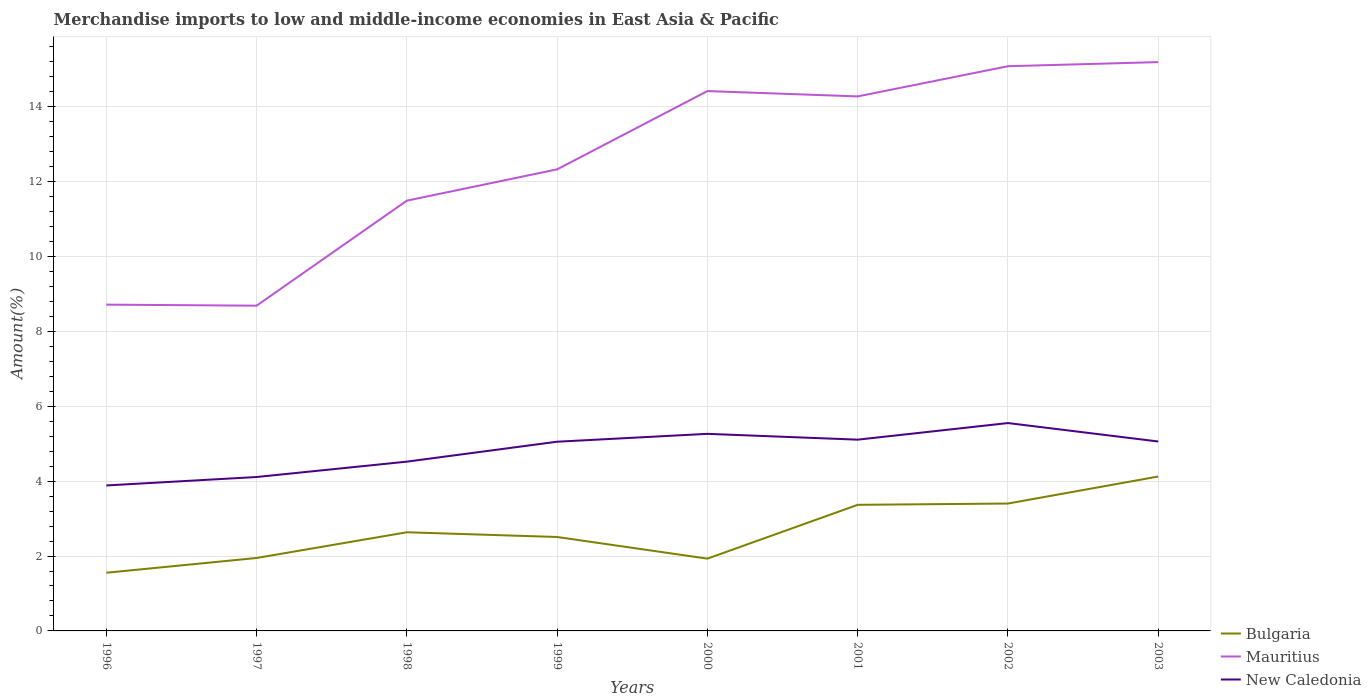How many different coloured lines are there?
Ensure brevity in your answer.  3. Across all years, what is the maximum percentage of amount earned from merchandise imports in Mauritius?
Offer a terse response. 8.69. In which year was the percentage of amount earned from merchandise imports in Mauritius maximum?
Make the answer very short. 1997. What is the total percentage of amount earned from merchandise imports in New Caledonia in the graph?
Your answer should be compact. -1.44. What is the difference between the highest and the second highest percentage of amount earned from merchandise imports in New Caledonia?
Offer a terse response. 1.67. What is the difference between the highest and the lowest percentage of amount earned from merchandise imports in Mauritius?
Provide a succinct answer. 4. How many years are there in the graph?
Offer a very short reply. 8. What is the difference between two consecutive major ticks on the Y-axis?
Provide a succinct answer. 2. Does the graph contain grids?
Give a very brief answer. Yes. How many legend labels are there?
Ensure brevity in your answer.  3. What is the title of the graph?
Offer a very short reply. Merchandise imports to low and middle-income economies in East Asia & Pacific. What is the label or title of the Y-axis?
Your answer should be very brief. Amount(%). What is the Amount(%) of Bulgaria in 1996?
Provide a short and direct response. 1.55. What is the Amount(%) in Mauritius in 1996?
Provide a succinct answer. 8.71. What is the Amount(%) in New Caledonia in 1996?
Your response must be concise. 3.88. What is the Amount(%) in Bulgaria in 1997?
Keep it short and to the point. 1.95. What is the Amount(%) of Mauritius in 1997?
Make the answer very short. 8.69. What is the Amount(%) in New Caledonia in 1997?
Make the answer very short. 4.11. What is the Amount(%) of Bulgaria in 1998?
Provide a short and direct response. 2.63. What is the Amount(%) in Mauritius in 1998?
Provide a succinct answer. 11.49. What is the Amount(%) of New Caledonia in 1998?
Give a very brief answer. 4.52. What is the Amount(%) in Bulgaria in 1999?
Your answer should be compact. 2.51. What is the Amount(%) of Mauritius in 1999?
Your answer should be compact. 12.33. What is the Amount(%) in New Caledonia in 1999?
Your answer should be compact. 5.05. What is the Amount(%) of Bulgaria in 2000?
Your response must be concise. 1.93. What is the Amount(%) in Mauritius in 2000?
Make the answer very short. 14.42. What is the Amount(%) in New Caledonia in 2000?
Your answer should be very brief. 5.26. What is the Amount(%) of Bulgaria in 2001?
Offer a very short reply. 3.37. What is the Amount(%) of Mauritius in 2001?
Give a very brief answer. 14.27. What is the Amount(%) in New Caledonia in 2001?
Provide a short and direct response. 5.11. What is the Amount(%) of Bulgaria in 2002?
Your answer should be very brief. 3.4. What is the Amount(%) of Mauritius in 2002?
Keep it short and to the point. 15.08. What is the Amount(%) of New Caledonia in 2002?
Offer a very short reply. 5.55. What is the Amount(%) in Bulgaria in 2003?
Ensure brevity in your answer.  4.12. What is the Amount(%) in Mauritius in 2003?
Ensure brevity in your answer.  15.19. What is the Amount(%) of New Caledonia in 2003?
Provide a short and direct response. 5.06. Across all years, what is the maximum Amount(%) in Bulgaria?
Provide a succinct answer. 4.12. Across all years, what is the maximum Amount(%) in Mauritius?
Ensure brevity in your answer.  15.19. Across all years, what is the maximum Amount(%) of New Caledonia?
Keep it short and to the point. 5.55. Across all years, what is the minimum Amount(%) of Bulgaria?
Make the answer very short. 1.55. Across all years, what is the minimum Amount(%) in Mauritius?
Provide a short and direct response. 8.69. Across all years, what is the minimum Amount(%) in New Caledonia?
Your response must be concise. 3.88. What is the total Amount(%) of Bulgaria in the graph?
Keep it short and to the point. 21.47. What is the total Amount(%) in Mauritius in the graph?
Give a very brief answer. 100.18. What is the total Amount(%) in New Caledonia in the graph?
Your answer should be compact. 38.55. What is the difference between the Amount(%) in Bulgaria in 1996 and that in 1997?
Provide a succinct answer. -0.39. What is the difference between the Amount(%) of Mauritius in 1996 and that in 1997?
Offer a terse response. 0.03. What is the difference between the Amount(%) in New Caledonia in 1996 and that in 1997?
Offer a terse response. -0.23. What is the difference between the Amount(%) of Bulgaria in 1996 and that in 1998?
Offer a terse response. -1.08. What is the difference between the Amount(%) in Mauritius in 1996 and that in 1998?
Keep it short and to the point. -2.78. What is the difference between the Amount(%) of New Caledonia in 1996 and that in 1998?
Your response must be concise. -0.64. What is the difference between the Amount(%) of Bulgaria in 1996 and that in 1999?
Provide a short and direct response. -0.95. What is the difference between the Amount(%) in Mauritius in 1996 and that in 1999?
Offer a very short reply. -3.61. What is the difference between the Amount(%) in New Caledonia in 1996 and that in 1999?
Make the answer very short. -1.17. What is the difference between the Amount(%) in Bulgaria in 1996 and that in 2000?
Offer a terse response. -0.38. What is the difference between the Amount(%) of Mauritius in 1996 and that in 2000?
Offer a very short reply. -5.7. What is the difference between the Amount(%) in New Caledonia in 1996 and that in 2000?
Offer a very short reply. -1.38. What is the difference between the Amount(%) in Bulgaria in 1996 and that in 2001?
Offer a terse response. -1.81. What is the difference between the Amount(%) of Mauritius in 1996 and that in 2001?
Keep it short and to the point. -5.56. What is the difference between the Amount(%) in New Caledonia in 1996 and that in 2001?
Your answer should be compact. -1.22. What is the difference between the Amount(%) in Bulgaria in 1996 and that in 2002?
Your answer should be very brief. -1.85. What is the difference between the Amount(%) of Mauritius in 1996 and that in 2002?
Make the answer very short. -6.37. What is the difference between the Amount(%) in New Caledonia in 1996 and that in 2002?
Provide a succinct answer. -1.67. What is the difference between the Amount(%) of Bulgaria in 1996 and that in 2003?
Your response must be concise. -2.57. What is the difference between the Amount(%) of Mauritius in 1996 and that in 2003?
Offer a very short reply. -6.48. What is the difference between the Amount(%) of New Caledonia in 1996 and that in 2003?
Offer a terse response. -1.17. What is the difference between the Amount(%) of Bulgaria in 1997 and that in 1998?
Offer a terse response. -0.69. What is the difference between the Amount(%) in Mauritius in 1997 and that in 1998?
Offer a very short reply. -2.8. What is the difference between the Amount(%) in New Caledonia in 1997 and that in 1998?
Your answer should be compact. -0.41. What is the difference between the Amount(%) of Bulgaria in 1997 and that in 1999?
Ensure brevity in your answer.  -0.56. What is the difference between the Amount(%) of Mauritius in 1997 and that in 1999?
Keep it short and to the point. -3.64. What is the difference between the Amount(%) of New Caledonia in 1997 and that in 1999?
Provide a short and direct response. -0.94. What is the difference between the Amount(%) in Bulgaria in 1997 and that in 2000?
Your answer should be compact. 0.02. What is the difference between the Amount(%) of Mauritius in 1997 and that in 2000?
Your response must be concise. -5.73. What is the difference between the Amount(%) of New Caledonia in 1997 and that in 2000?
Your answer should be compact. -1.15. What is the difference between the Amount(%) of Bulgaria in 1997 and that in 2001?
Provide a succinct answer. -1.42. What is the difference between the Amount(%) of Mauritius in 1997 and that in 2001?
Your answer should be very brief. -5.59. What is the difference between the Amount(%) in New Caledonia in 1997 and that in 2001?
Offer a terse response. -1. What is the difference between the Amount(%) of Bulgaria in 1997 and that in 2002?
Keep it short and to the point. -1.45. What is the difference between the Amount(%) of Mauritius in 1997 and that in 2002?
Offer a very short reply. -6.39. What is the difference between the Amount(%) in New Caledonia in 1997 and that in 2002?
Your response must be concise. -1.44. What is the difference between the Amount(%) in Bulgaria in 1997 and that in 2003?
Provide a short and direct response. -2.18. What is the difference between the Amount(%) in Mauritius in 1997 and that in 2003?
Your answer should be compact. -6.5. What is the difference between the Amount(%) of New Caledonia in 1997 and that in 2003?
Your response must be concise. -0.95. What is the difference between the Amount(%) in Bulgaria in 1998 and that in 1999?
Make the answer very short. 0.13. What is the difference between the Amount(%) in Mauritius in 1998 and that in 1999?
Offer a very short reply. -0.84. What is the difference between the Amount(%) in New Caledonia in 1998 and that in 1999?
Offer a very short reply. -0.53. What is the difference between the Amount(%) of Bulgaria in 1998 and that in 2000?
Keep it short and to the point. 0.7. What is the difference between the Amount(%) in Mauritius in 1998 and that in 2000?
Your response must be concise. -2.93. What is the difference between the Amount(%) of New Caledonia in 1998 and that in 2000?
Offer a terse response. -0.74. What is the difference between the Amount(%) in Bulgaria in 1998 and that in 2001?
Give a very brief answer. -0.73. What is the difference between the Amount(%) of Mauritius in 1998 and that in 2001?
Give a very brief answer. -2.78. What is the difference between the Amount(%) in New Caledonia in 1998 and that in 2001?
Provide a succinct answer. -0.59. What is the difference between the Amount(%) in Bulgaria in 1998 and that in 2002?
Your answer should be very brief. -0.77. What is the difference between the Amount(%) of Mauritius in 1998 and that in 2002?
Offer a very short reply. -3.59. What is the difference between the Amount(%) of New Caledonia in 1998 and that in 2002?
Make the answer very short. -1.03. What is the difference between the Amount(%) in Bulgaria in 1998 and that in 2003?
Make the answer very short. -1.49. What is the difference between the Amount(%) of Mauritius in 1998 and that in 2003?
Offer a very short reply. -3.7. What is the difference between the Amount(%) of New Caledonia in 1998 and that in 2003?
Provide a succinct answer. -0.54. What is the difference between the Amount(%) in Bulgaria in 1999 and that in 2000?
Ensure brevity in your answer.  0.58. What is the difference between the Amount(%) in Mauritius in 1999 and that in 2000?
Ensure brevity in your answer.  -2.09. What is the difference between the Amount(%) of New Caledonia in 1999 and that in 2000?
Ensure brevity in your answer.  -0.21. What is the difference between the Amount(%) of Bulgaria in 1999 and that in 2001?
Offer a very short reply. -0.86. What is the difference between the Amount(%) in Mauritius in 1999 and that in 2001?
Your answer should be very brief. -1.95. What is the difference between the Amount(%) in New Caledonia in 1999 and that in 2001?
Ensure brevity in your answer.  -0.05. What is the difference between the Amount(%) in Bulgaria in 1999 and that in 2002?
Your answer should be compact. -0.89. What is the difference between the Amount(%) of Mauritius in 1999 and that in 2002?
Ensure brevity in your answer.  -2.75. What is the difference between the Amount(%) of New Caledonia in 1999 and that in 2002?
Offer a very short reply. -0.5. What is the difference between the Amount(%) in Bulgaria in 1999 and that in 2003?
Ensure brevity in your answer.  -1.62. What is the difference between the Amount(%) of Mauritius in 1999 and that in 2003?
Your answer should be very brief. -2.86. What is the difference between the Amount(%) of New Caledonia in 1999 and that in 2003?
Provide a succinct answer. -0.01. What is the difference between the Amount(%) of Bulgaria in 2000 and that in 2001?
Provide a short and direct response. -1.44. What is the difference between the Amount(%) of Mauritius in 2000 and that in 2001?
Offer a terse response. 0.14. What is the difference between the Amount(%) of New Caledonia in 2000 and that in 2001?
Make the answer very short. 0.16. What is the difference between the Amount(%) in Bulgaria in 2000 and that in 2002?
Provide a short and direct response. -1.47. What is the difference between the Amount(%) in Mauritius in 2000 and that in 2002?
Give a very brief answer. -0.66. What is the difference between the Amount(%) of New Caledonia in 2000 and that in 2002?
Give a very brief answer. -0.29. What is the difference between the Amount(%) of Bulgaria in 2000 and that in 2003?
Provide a short and direct response. -2.19. What is the difference between the Amount(%) in Mauritius in 2000 and that in 2003?
Your answer should be compact. -0.77. What is the difference between the Amount(%) in New Caledonia in 2000 and that in 2003?
Offer a very short reply. 0.2. What is the difference between the Amount(%) of Bulgaria in 2001 and that in 2002?
Provide a succinct answer. -0.03. What is the difference between the Amount(%) in Mauritius in 2001 and that in 2002?
Offer a very short reply. -0.81. What is the difference between the Amount(%) of New Caledonia in 2001 and that in 2002?
Your answer should be very brief. -0.44. What is the difference between the Amount(%) in Bulgaria in 2001 and that in 2003?
Your answer should be compact. -0.76. What is the difference between the Amount(%) of Mauritius in 2001 and that in 2003?
Your answer should be very brief. -0.92. What is the difference between the Amount(%) of New Caledonia in 2001 and that in 2003?
Your response must be concise. 0.05. What is the difference between the Amount(%) in Bulgaria in 2002 and that in 2003?
Keep it short and to the point. -0.72. What is the difference between the Amount(%) of Mauritius in 2002 and that in 2003?
Give a very brief answer. -0.11. What is the difference between the Amount(%) of New Caledonia in 2002 and that in 2003?
Keep it short and to the point. 0.49. What is the difference between the Amount(%) of Bulgaria in 1996 and the Amount(%) of Mauritius in 1997?
Provide a succinct answer. -7.13. What is the difference between the Amount(%) of Bulgaria in 1996 and the Amount(%) of New Caledonia in 1997?
Provide a succinct answer. -2.56. What is the difference between the Amount(%) in Mauritius in 1996 and the Amount(%) in New Caledonia in 1997?
Offer a very short reply. 4.6. What is the difference between the Amount(%) in Bulgaria in 1996 and the Amount(%) in Mauritius in 1998?
Offer a terse response. -9.94. What is the difference between the Amount(%) in Bulgaria in 1996 and the Amount(%) in New Caledonia in 1998?
Give a very brief answer. -2.97. What is the difference between the Amount(%) of Mauritius in 1996 and the Amount(%) of New Caledonia in 1998?
Offer a very short reply. 4.19. What is the difference between the Amount(%) of Bulgaria in 1996 and the Amount(%) of Mauritius in 1999?
Your answer should be very brief. -10.77. What is the difference between the Amount(%) of Bulgaria in 1996 and the Amount(%) of New Caledonia in 1999?
Offer a very short reply. -3.5. What is the difference between the Amount(%) of Mauritius in 1996 and the Amount(%) of New Caledonia in 1999?
Give a very brief answer. 3.66. What is the difference between the Amount(%) of Bulgaria in 1996 and the Amount(%) of Mauritius in 2000?
Offer a very short reply. -12.86. What is the difference between the Amount(%) of Bulgaria in 1996 and the Amount(%) of New Caledonia in 2000?
Your answer should be very brief. -3.71. What is the difference between the Amount(%) in Mauritius in 1996 and the Amount(%) in New Caledonia in 2000?
Make the answer very short. 3.45. What is the difference between the Amount(%) of Bulgaria in 1996 and the Amount(%) of Mauritius in 2001?
Ensure brevity in your answer.  -12.72. What is the difference between the Amount(%) in Bulgaria in 1996 and the Amount(%) in New Caledonia in 2001?
Keep it short and to the point. -3.55. What is the difference between the Amount(%) of Mauritius in 1996 and the Amount(%) of New Caledonia in 2001?
Provide a succinct answer. 3.61. What is the difference between the Amount(%) of Bulgaria in 1996 and the Amount(%) of Mauritius in 2002?
Your answer should be very brief. -13.53. What is the difference between the Amount(%) of Bulgaria in 1996 and the Amount(%) of New Caledonia in 2002?
Give a very brief answer. -4. What is the difference between the Amount(%) in Mauritius in 1996 and the Amount(%) in New Caledonia in 2002?
Offer a terse response. 3.16. What is the difference between the Amount(%) of Bulgaria in 1996 and the Amount(%) of Mauritius in 2003?
Provide a succinct answer. -13.64. What is the difference between the Amount(%) in Bulgaria in 1996 and the Amount(%) in New Caledonia in 2003?
Offer a very short reply. -3.51. What is the difference between the Amount(%) of Mauritius in 1996 and the Amount(%) of New Caledonia in 2003?
Your answer should be compact. 3.65. What is the difference between the Amount(%) in Bulgaria in 1997 and the Amount(%) in Mauritius in 1998?
Offer a very short reply. -9.54. What is the difference between the Amount(%) of Bulgaria in 1997 and the Amount(%) of New Caledonia in 1998?
Your response must be concise. -2.57. What is the difference between the Amount(%) in Mauritius in 1997 and the Amount(%) in New Caledonia in 1998?
Provide a short and direct response. 4.17. What is the difference between the Amount(%) of Bulgaria in 1997 and the Amount(%) of Mauritius in 1999?
Offer a terse response. -10.38. What is the difference between the Amount(%) in Bulgaria in 1997 and the Amount(%) in New Caledonia in 1999?
Ensure brevity in your answer.  -3.11. What is the difference between the Amount(%) in Mauritius in 1997 and the Amount(%) in New Caledonia in 1999?
Offer a terse response. 3.63. What is the difference between the Amount(%) in Bulgaria in 1997 and the Amount(%) in Mauritius in 2000?
Your response must be concise. -12.47. What is the difference between the Amount(%) in Bulgaria in 1997 and the Amount(%) in New Caledonia in 2000?
Offer a terse response. -3.32. What is the difference between the Amount(%) of Mauritius in 1997 and the Amount(%) of New Caledonia in 2000?
Your answer should be very brief. 3.42. What is the difference between the Amount(%) of Bulgaria in 1997 and the Amount(%) of Mauritius in 2001?
Provide a short and direct response. -12.33. What is the difference between the Amount(%) of Bulgaria in 1997 and the Amount(%) of New Caledonia in 2001?
Your answer should be compact. -3.16. What is the difference between the Amount(%) of Mauritius in 1997 and the Amount(%) of New Caledonia in 2001?
Your response must be concise. 3.58. What is the difference between the Amount(%) in Bulgaria in 1997 and the Amount(%) in Mauritius in 2002?
Keep it short and to the point. -13.13. What is the difference between the Amount(%) of Bulgaria in 1997 and the Amount(%) of New Caledonia in 2002?
Keep it short and to the point. -3.6. What is the difference between the Amount(%) of Mauritius in 1997 and the Amount(%) of New Caledonia in 2002?
Your answer should be compact. 3.14. What is the difference between the Amount(%) of Bulgaria in 1997 and the Amount(%) of Mauritius in 2003?
Your answer should be very brief. -13.24. What is the difference between the Amount(%) of Bulgaria in 1997 and the Amount(%) of New Caledonia in 2003?
Ensure brevity in your answer.  -3.11. What is the difference between the Amount(%) in Mauritius in 1997 and the Amount(%) in New Caledonia in 2003?
Give a very brief answer. 3.63. What is the difference between the Amount(%) of Bulgaria in 1998 and the Amount(%) of Mauritius in 1999?
Ensure brevity in your answer.  -9.69. What is the difference between the Amount(%) in Bulgaria in 1998 and the Amount(%) in New Caledonia in 1999?
Your answer should be compact. -2.42. What is the difference between the Amount(%) of Mauritius in 1998 and the Amount(%) of New Caledonia in 1999?
Your answer should be compact. 6.44. What is the difference between the Amount(%) in Bulgaria in 1998 and the Amount(%) in Mauritius in 2000?
Your answer should be very brief. -11.78. What is the difference between the Amount(%) in Bulgaria in 1998 and the Amount(%) in New Caledonia in 2000?
Give a very brief answer. -2.63. What is the difference between the Amount(%) in Mauritius in 1998 and the Amount(%) in New Caledonia in 2000?
Provide a succinct answer. 6.23. What is the difference between the Amount(%) in Bulgaria in 1998 and the Amount(%) in Mauritius in 2001?
Give a very brief answer. -11.64. What is the difference between the Amount(%) of Bulgaria in 1998 and the Amount(%) of New Caledonia in 2001?
Offer a terse response. -2.47. What is the difference between the Amount(%) of Mauritius in 1998 and the Amount(%) of New Caledonia in 2001?
Make the answer very short. 6.38. What is the difference between the Amount(%) of Bulgaria in 1998 and the Amount(%) of Mauritius in 2002?
Provide a succinct answer. -12.45. What is the difference between the Amount(%) of Bulgaria in 1998 and the Amount(%) of New Caledonia in 2002?
Offer a very short reply. -2.92. What is the difference between the Amount(%) in Mauritius in 1998 and the Amount(%) in New Caledonia in 2002?
Your response must be concise. 5.94. What is the difference between the Amount(%) in Bulgaria in 1998 and the Amount(%) in Mauritius in 2003?
Give a very brief answer. -12.56. What is the difference between the Amount(%) of Bulgaria in 1998 and the Amount(%) of New Caledonia in 2003?
Your answer should be very brief. -2.42. What is the difference between the Amount(%) in Mauritius in 1998 and the Amount(%) in New Caledonia in 2003?
Give a very brief answer. 6.43. What is the difference between the Amount(%) of Bulgaria in 1999 and the Amount(%) of Mauritius in 2000?
Offer a very short reply. -11.91. What is the difference between the Amount(%) in Bulgaria in 1999 and the Amount(%) in New Caledonia in 2000?
Provide a succinct answer. -2.75. What is the difference between the Amount(%) of Mauritius in 1999 and the Amount(%) of New Caledonia in 2000?
Provide a succinct answer. 7.06. What is the difference between the Amount(%) in Bulgaria in 1999 and the Amount(%) in Mauritius in 2001?
Your answer should be very brief. -11.77. What is the difference between the Amount(%) of Bulgaria in 1999 and the Amount(%) of New Caledonia in 2001?
Your answer should be compact. -2.6. What is the difference between the Amount(%) in Mauritius in 1999 and the Amount(%) in New Caledonia in 2001?
Keep it short and to the point. 7.22. What is the difference between the Amount(%) of Bulgaria in 1999 and the Amount(%) of Mauritius in 2002?
Keep it short and to the point. -12.57. What is the difference between the Amount(%) of Bulgaria in 1999 and the Amount(%) of New Caledonia in 2002?
Offer a terse response. -3.04. What is the difference between the Amount(%) of Mauritius in 1999 and the Amount(%) of New Caledonia in 2002?
Offer a terse response. 6.78. What is the difference between the Amount(%) in Bulgaria in 1999 and the Amount(%) in Mauritius in 2003?
Provide a succinct answer. -12.68. What is the difference between the Amount(%) in Bulgaria in 1999 and the Amount(%) in New Caledonia in 2003?
Your response must be concise. -2.55. What is the difference between the Amount(%) in Mauritius in 1999 and the Amount(%) in New Caledonia in 2003?
Make the answer very short. 7.27. What is the difference between the Amount(%) in Bulgaria in 2000 and the Amount(%) in Mauritius in 2001?
Your response must be concise. -12.34. What is the difference between the Amount(%) of Bulgaria in 2000 and the Amount(%) of New Caledonia in 2001?
Provide a succinct answer. -3.18. What is the difference between the Amount(%) of Mauritius in 2000 and the Amount(%) of New Caledonia in 2001?
Make the answer very short. 9.31. What is the difference between the Amount(%) in Bulgaria in 2000 and the Amount(%) in Mauritius in 2002?
Provide a succinct answer. -13.15. What is the difference between the Amount(%) in Bulgaria in 2000 and the Amount(%) in New Caledonia in 2002?
Offer a terse response. -3.62. What is the difference between the Amount(%) of Mauritius in 2000 and the Amount(%) of New Caledonia in 2002?
Ensure brevity in your answer.  8.87. What is the difference between the Amount(%) of Bulgaria in 2000 and the Amount(%) of Mauritius in 2003?
Your response must be concise. -13.26. What is the difference between the Amount(%) of Bulgaria in 2000 and the Amount(%) of New Caledonia in 2003?
Provide a succinct answer. -3.13. What is the difference between the Amount(%) in Mauritius in 2000 and the Amount(%) in New Caledonia in 2003?
Offer a very short reply. 9.36. What is the difference between the Amount(%) of Bulgaria in 2001 and the Amount(%) of Mauritius in 2002?
Your response must be concise. -11.71. What is the difference between the Amount(%) of Bulgaria in 2001 and the Amount(%) of New Caledonia in 2002?
Keep it short and to the point. -2.18. What is the difference between the Amount(%) of Mauritius in 2001 and the Amount(%) of New Caledonia in 2002?
Provide a succinct answer. 8.72. What is the difference between the Amount(%) in Bulgaria in 2001 and the Amount(%) in Mauritius in 2003?
Make the answer very short. -11.82. What is the difference between the Amount(%) of Bulgaria in 2001 and the Amount(%) of New Caledonia in 2003?
Keep it short and to the point. -1.69. What is the difference between the Amount(%) in Mauritius in 2001 and the Amount(%) in New Caledonia in 2003?
Give a very brief answer. 9.22. What is the difference between the Amount(%) in Bulgaria in 2002 and the Amount(%) in Mauritius in 2003?
Ensure brevity in your answer.  -11.79. What is the difference between the Amount(%) in Bulgaria in 2002 and the Amount(%) in New Caledonia in 2003?
Offer a terse response. -1.66. What is the difference between the Amount(%) of Mauritius in 2002 and the Amount(%) of New Caledonia in 2003?
Offer a very short reply. 10.02. What is the average Amount(%) of Bulgaria per year?
Ensure brevity in your answer.  2.68. What is the average Amount(%) in Mauritius per year?
Provide a succinct answer. 12.52. What is the average Amount(%) of New Caledonia per year?
Keep it short and to the point. 4.82. In the year 1996, what is the difference between the Amount(%) in Bulgaria and Amount(%) in Mauritius?
Keep it short and to the point. -7.16. In the year 1996, what is the difference between the Amount(%) in Bulgaria and Amount(%) in New Caledonia?
Provide a succinct answer. -2.33. In the year 1996, what is the difference between the Amount(%) in Mauritius and Amount(%) in New Caledonia?
Make the answer very short. 4.83. In the year 1997, what is the difference between the Amount(%) of Bulgaria and Amount(%) of Mauritius?
Offer a very short reply. -6.74. In the year 1997, what is the difference between the Amount(%) of Bulgaria and Amount(%) of New Caledonia?
Your answer should be compact. -2.16. In the year 1997, what is the difference between the Amount(%) in Mauritius and Amount(%) in New Caledonia?
Provide a succinct answer. 4.58. In the year 1998, what is the difference between the Amount(%) of Bulgaria and Amount(%) of Mauritius?
Your answer should be very brief. -8.86. In the year 1998, what is the difference between the Amount(%) of Bulgaria and Amount(%) of New Caledonia?
Your answer should be compact. -1.89. In the year 1998, what is the difference between the Amount(%) of Mauritius and Amount(%) of New Caledonia?
Ensure brevity in your answer.  6.97. In the year 1999, what is the difference between the Amount(%) in Bulgaria and Amount(%) in Mauritius?
Provide a short and direct response. -9.82. In the year 1999, what is the difference between the Amount(%) in Bulgaria and Amount(%) in New Caledonia?
Your answer should be very brief. -2.54. In the year 1999, what is the difference between the Amount(%) of Mauritius and Amount(%) of New Caledonia?
Offer a terse response. 7.27. In the year 2000, what is the difference between the Amount(%) of Bulgaria and Amount(%) of Mauritius?
Your response must be concise. -12.49. In the year 2000, what is the difference between the Amount(%) of Bulgaria and Amount(%) of New Caledonia?
Keep it short and to the point. -3.33. In the year 2000, what is the difference between the Amount(%) of Mauritius and Amount(%) of New Caledonia?
Offer a very short reply. 9.15. In the year 2001, what is the difference between the Amount(%) of Bulgaria and Amount(%) of Mauritius?
Your answer should be compact. -10.91. In the year 2001, what is the difference between the Amount(%) of Bulgaria and Amount(%) of New Caledonia?
Your answer should be compact. -1.74. In the year 2001, what is the difference between the Amount(%) of Mauritius and Amount(%) of New Caledonia?
Provide a succinct answer. 9.17. In the year 2002, what is the difference between the Amount(%) of Bulgaria and Amount(%) of Mauritius?
Offer a very short reply. -11.68. In the year 2002, what is the difference between the Amount(%) of Bulgaria and Amount(%) of New Caledonia?
Your answer should be very brief. -2.15. In the year 2002, what is the difference between the Amount(%) in Mauritius and Amount(%) in New Caledonia?
Give a very brief answer. 9.53. In the year 2003, what is the difference between the Amount(%) of Bulgaria and Amount(%) of Mauritius?
Provide a short and direct response. -11.07. In the year 2003, what is the difference between the Amount(%) of Bulgaria and Amount(%) of New Caledonia?
Keep it short and to the point. -0.94. In the year 2003, what is the difference between the Amount(%) in Mauritius and Amount(%) in New Caledonia?
Provide a short and direct response. 10.13. What is the ratio of the Amount(%) in Bulgaria in 1996 to that in 1997?
Offer a terse response. 0.8. What is the ratio of the Amount(%) of New Caledonia in 1996 to that in 1997?
Your answer should be very brief. 0.95. What is the ratio of the Amount(%) of Bulgaria in 1996 to that in 1998?
Offer a terse response. 0.59. What is the ratio of the Amount(%) in Mauritius in 1996 to that in 1998?
Your answer should be very brief. 0.76. What is the ratio of the Amount(%) of New Caledonia in 1996 to that in 1998?
Offer a terse response. 0.86. What is the ratio of the Amount(%) in Bulgaria in 1996 to that in 1999?
Keep it short and to the point. 0.62. What is the ratio of the Amount(%) of Mauritius in 1996 to that in 1999?
Your answer should be very brief. 0.71. What is the ratio of the Amount(%) of New Caledonia in 1996 to that in 1999?
Ensure brevity in your answer.  0.77. What is the ratio of the Amount(%) in Bulgaria in 1996 to that in 2000?
Keep it short and to the point. 0.8. What is the ratio of the Amount(%) of Mauritius in 1996 to that in 2000?
Give a very brief answer. 0.6. What is the ratio of the Amount(%) of New Caledonia in 1996 to that in 2000?
Make the answer very short. 0.74. What is the ratio of the Amount(%) in Bulgaria in 1996 to that in 2001?
Your answer should be compact. 0.46. What is the ratio of the Amount(%) of Mauritius in 1996 to that in 2001?
Your answer should be very brief. 0.61. What is the ratio of the Amount(%) of New Caledonia in 1996 to that in 2001?
Make the answer very short. 0.76. What is the ratio of the Amount(%) in Bulgaria in 1996 to that in 2002?
Ensure brevity in your answer.  0.46. What is the ratio of the Amount(%) of Mauritius in 1996 to that in 2002?
Keep it short and to the point. 0.58. What is the ratio of the Amount(%) of New Caledonia in 1996 to that in 2002?
Give a very brief answer. 0.7. What is the ratio of the Amount(%) in Bulgaria in 1996 to that in 2003?
Offer a very short reply. 0.38. What is the ratio of the Amount(%) in Mauritius in 1996 to that in 2003?
Keep it short and to the point. 0.57. What is the ratio of the Amount(%) of New Caledonia in 1996 to that in 2003?
Offer a very short reply. 0.77. What is the ratio of the Amount(%) of Bulgaria in 1997 to that in 1998?
Ensure brevity in your answer.  0.74. What is the ratio of the Amount(%) in Mauritius in 1997 to that in 1998?
Offer a very short reply. 0.76. What is the ratio of the Amount(%) of New Caledonia in 1997 to that in 1998?
Offer a terse response. 0.91. What is the ratio of the Amount(%) of Bulgaria in 1997 to that in 1999?
Ensure brevity in your answer.  0.78. What is the ratio of the Amount(%) in Mauritius in 1997 to that in 1999?
Provide a succinct answer. 0.7. What is the ratio of the Amount(%) in New Caledonia in 1997 to that in 1999?
Your answer should be compact. 0.81. What is the ratio of the Amount(%) in Bulgaria in 1997 to that in 2000?
Offer a terse response. 1.01. What is the ratio of the Amount(%) in Mauritius in 1997 to that in 2000?
Your answer should be compact. 0.6. What is the ratio of the Amount(%) in New Caledonia in 1997 to that in 2000?
Keep it short and to the point. 0.78. What is the ratio of the Amount(%) in Bulgaria in 1997 to that in 2001?
Your answer should be compact. 0.58. What is the ratio of the Amount(%) in Mauritius in 1997 to that in 2001?
Your answer should be compact. 0.61. What is the ratio of the Amount(%) of New Caledonia in 1997 to that in 2001?
Make the answer very short. 0.8. What is the ratio of the Amount(%) in Bulgaria in 1997 to that in 2002?
Provide a succinct answer. 0.57. What is the ratio of the Amount(%) of Mauritius in 1997 to that in 2002?
Ensure brevity in your answer.  0.58. What is the ratio of the Amount(%) in New Caledonia in 1997 to that in 2002?
Your answer should be very brief. 0.74. What is the ratio of the Amount(%) in Bulgaria in 1997 to that in 2003?
Give a very brief answer. 0.47. What is the ratio of the Amount(%) of Mauritius in 1997 to that in 2003?
Provide a short and direct response. 0.57. What is the ratio of the Amount(%) of New Caledonia in 1997 to that in 2003?
Your response must be concise. 0.81. What is the ratio of the Amount(%) of Bulgaria in 1998 to that in 1999?
Give a very brief answer. 1.05. What is the ratio of the Amount(%) in Mauritius in 1998 to that in 1999?
Provide a succinct answer. 0.93. What is the ratio of the Amount(%) in New Caledonia in 1998 to that in 1999?
Make the answer very short. 0.89. What is the ratio of the Amount(%) in Bulgaria in 1998 to that in 2000?
Make the answer very short. 1.36. What is the ratio of the Amount(%) of Mauritius in 1998 to that in 2000?
Keep it short and to the point. 0.8. What is the ratio of the Amount(%) in New Caledonia in 1998 to that in 2000?
Your answer should be compact. 0.86. What is the ratio of the Amount(%) in Bulgaria in 1998 to that in 2001?
Ensure brevity in your answer.  0.78. What is the ratio of the Amount(%) in Mauritius in 1998 to that in 2001?
Offer a very short reply. 0.81. What is the ratio of the Amount(%) of New Caledonia in 1998 to that in 2001?
Your answer should be very brief. 0.89. What is the ratio of the Amount(%) in Bulgaria in 1998 to that in 2002?
Offer a very short reply. 0.77. What is the ratio of the Amount(%) in Mauritius in 1998 to that in 2002?
Ensure brevity in your answer.  0.76. What is the ratio of the Amount(%) in New Caledonia in 1998 to that in 2002?
Make the answer very short. 0.81. What is the ratio of the Amount(%) of Bulgaria in 1998 to that in 2003?
Your answer should be compact. 0.64. What is the ratio of the Amount(%) in Mauritius in 1998 to that in 2003?
Provide a short and direct response. 0.76. What is the ratio of the Amount(%) in New Caledonia in 1998 to that in 2003?
Offer a very short reply. 0.89. What is the ratio of the Amount(%) in Bulgaria in 1999 to that in 2000?
Give a very brief answer. 1.3. What is the ratio of the Amount(%) in Mauritius in 1999 to that in 2000?
Offer a very short reply. 0.85. What is the ratio of the Amount(%) in New Caledonia in 1999 to that in 2000?
Keep it short and to the point. 0.96. What is the ratio of the Amount(%) of Bulgaria in 1999 to that in 2001?
Provide a short and direct response. 0.74. What is the ratio of the Amount(%) in Mauritius in 1999 to that in 2001?
Keep it short and to the point. 0.86. What is the ratio of the Amount(%) of New Caledonia in 1999 to that in 2001?
Your answer should be compact. 0.99. What is the ratio of the Amount(%) in Bulgaria in 1999 to that in 2002?
Give a very brief answer. 0.74. What is the ratio of the Amount(%) in Mauritius in 1999 to that in 2002?
Ensure brevity in your answer.  0.82. What is the ratio of the Amount(%) of New Caledonia in 1999 to that in 2002?
Your answer should be very brief. 0.91. What is the ratio of the Amount(%) of Bulgaria in 1999 to that in 2003?
Provide a short and direct response. 0.61. What is the ratio of the Amount(%) in Mauritius in 1999 to that in 2003?
Offer a terse response. 0.81. What is the ratio of the Amount(%) in New Caledonia in 1999 to that in 2003?
Ensure brevity in your answer.  1. What is the ratio of the Amount(%) of Bulgaria in 2000 to that in 2001?
Provide a succinct answer. 0.57. What is the ratio of the Amount(%) of New Caledonia in 2000 to that in 2001?
Your response must be concise. 1.03. What is the ratio of the Amount(%) in Bulgaria in 2000 to that in 2002?
Keep it short and to the point. 0.57. What is the ratio of the Amount(%) in Mauritius in 2000 to that in 2002?
Offer a very short reply. 0.96. What is the ratio of the Amount(%) in New Caledonia in 2000 to that in 2002?
Your response must be concise. 0.95. What is the ratio of the Amount(%) of Bulgaria in 2000 to that in 2003?
Your answer should be compact. 0.47. What is the ratio of the Amount(%) in Mauritius in 2000 to that in 2003?
Make the answer very short. 0.95. What is the ratio of the Amount(%) of New Caledonia in 2000 to that in 2003?
Your answer should be very brief. 1.04. What is the ratio of the Amount(%) of Mauritius in 2001 to that in 2002?
Provide a short and direct response. 0.95. What is the ratio of the Amount(%) in New Caledonia in 2001 to that in 2002?
Give a very brief answer. 0.92. What is the ratio of the Amount(%) of Bulgaria in 2001 to that in 2003?
Give a very brief answer. 0.82. What is the ratio of the Amount(%) in Mauritius in 2001 to that in 2003?
Your answer should be very brief. 0.94. What is the ratio of the Amount(%) in New Caledonia in 2001 to that in 2003?
Offer a terse response. 1.01. What is the ratio of the Amount(%) of Bulgaria in 2002 to that in 2003?
Offer a very short reply. 0.82. What is the ratio of the Amount(%) in Mauritius in 2002 to that in 2003?
Your response must be concise. 0.99. What is the ratio of the Amount(%) of New Caledonia in 2002 to that in 2003?
Give a very brief answer. 1.1. What is the difference between the highest and the second highest Amount(%) in Bulgaria?
Keep it short and to the point. 0.72. What is the difference between the highest and the second highest Amount(%) in Mauritius?
Give a very brief answer. 0.11. What is the difference between the highest and the second highest Amount(%) of New Caledonia?
Offer a very short reply. 0.29. What is the difference between the highest and the lowest Amount(%) in Bulgaria?
Offer a very short reply. 2.57. What is the difference between the highest and the lowest Amount(%) in Mauritius?
Keep it short and to the point. 6.5. What is the difference between the highest and the lowest Amount(%) in New Caledonia?
Give a very brief answer. 1.67. 